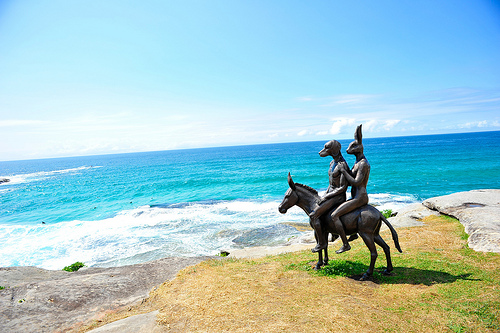<image>
Is there a bunny under the donkey? No. The bunny is not positioned under the donkey. The vertical relationship between these objects is different. 